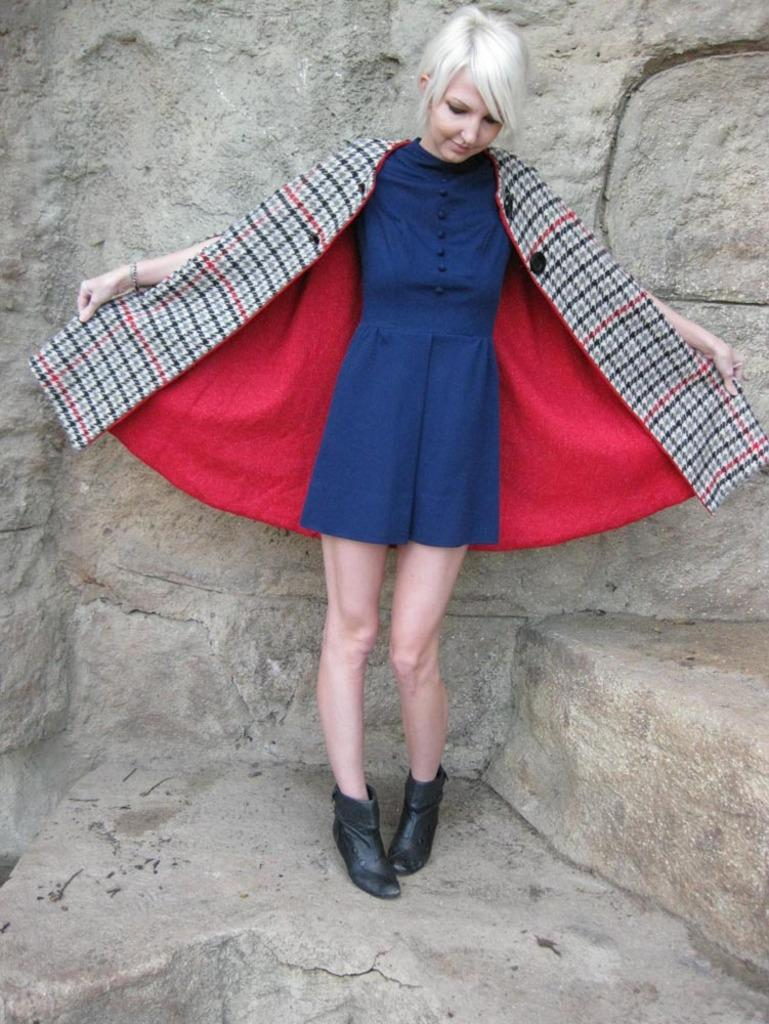Who is present in the image? There is a woman in the image. What is the woman doing in the image? The woman is standing in the image. What is the woman holding in her hands? The woman is holding a dress in her hands. What is the woman wearing? The woman is wearing a blue dress and black shoes. What can be seen in the background of the image? There is a wall in the background of the image. What type of pan is the woman using to cook in the image? There is no pan or cooking activity present in the image. What color are the crayons that the woman is using to draw in the image? There are no crayons or drawing activity present in the image. 